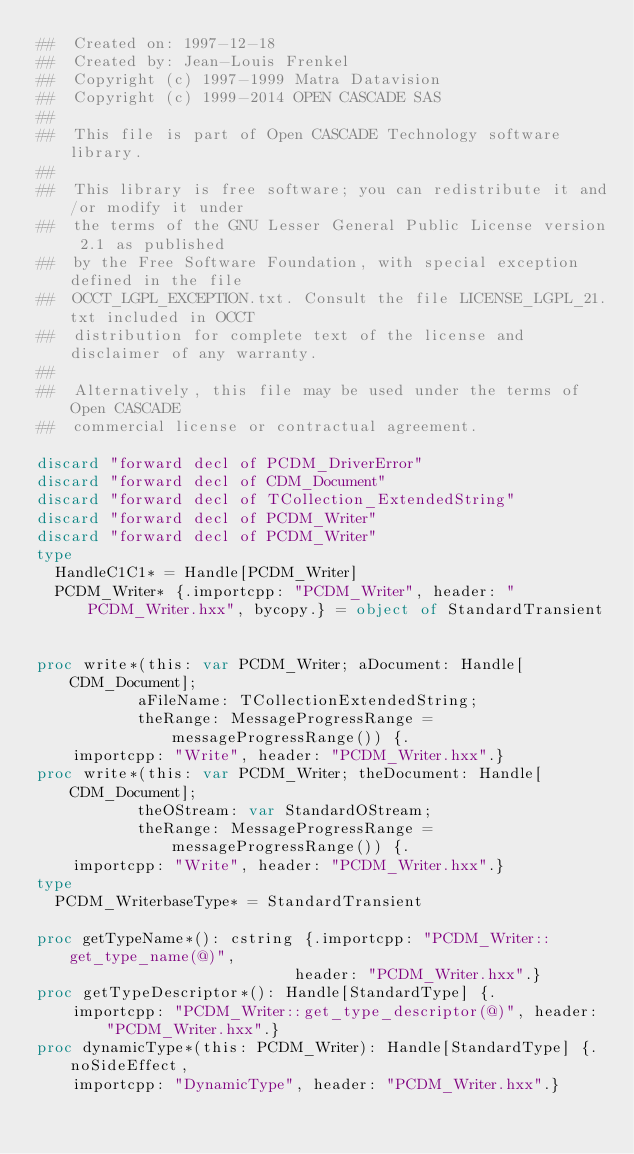<code> <loc_0><loc_0><loc_500><loc_500><_Nim_>##  Created on: 1997-12-18
##  Created by: Jean-Louis Frenkel
##  Copyright (c) 1997-1999 Matra Datavision
##  Copyright (c) 1999-2014 OPEN CASCADE SAS
##
##  This file is part of Open CASCADE Technology software library.
##
##  This library is free software; you can redistribute it and/or modify it under
##  the terms of the GNU Lesser General Public License version 2.1 as published
##  by the Free Software Foundation, with special exception defined in the file
##  OCCT_LGPL_EXCEPTION.txt. Consult the file LICENSE_LGPL_21.txt included in OCCT
##  distribution for complete text of the license and disclaimer of any warranty.
##
##  Alternatively, this file may be used under the terms of Open CASCADE
##  commercial license or contractual agreement.

discard "forward decl of PCDM_DriverError"
discard "forward decl of CDM_Document"
discard "forward decl of TCollection_ExtendedString"
discard "forward decl of PCDM_Writer"
discard "forward decl of PCDM_Writer"
type
  HandleC1C1* = Handle[PCDM_Writer]
  PCDM_Writer* {.importcpp: "PCDM_Writer", header: "PCDM_Writer.hxx", bycopy.} = object of StandardTransient


proc write*(this: var PCDM_Writer; aDocument: Handle[CDM_Document];
           aFileName: TCollectionExtendedString;
           theRange: MessageProgressRange = messageProgressRange()) {.
    importcpp: "Write", header: "PCDM_Writer.hxx".}
proc write*(this: var PCDM_Writer; theDocument: Handle[CDM_Document];
           theOStream: var StandardOStream;
           theRange: MessageProgressRange = messageProgressRange()) {.
    importcpp: "Write", header: "PCDM_Writer.hxx".}
type
  PCDM_WriterbaseType* = StandardTransient

proc getTypeName*(): cstring {.importcpp: "PCDM_Writer::get_type_name(@)",
                            header: "PCDM_Writer.hxx".}
proc getTypeDescriptor*(): Handle[StandardType] {.
    importcpp: "PCDM_Writer::get_type_descriptor(@)", header: "PCDM_Writer.hxx".}
proc dynamicType*(this: PCDM_Writer): Handle[StandardType] {.noSideEffect,
    importcpp: "DynamicType", header: "PCDM_Writer.hxx".}

























</code> 